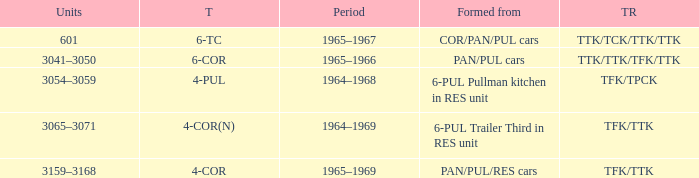Name the formed that has type of 4-cor PAN/PUL/RES cars. 